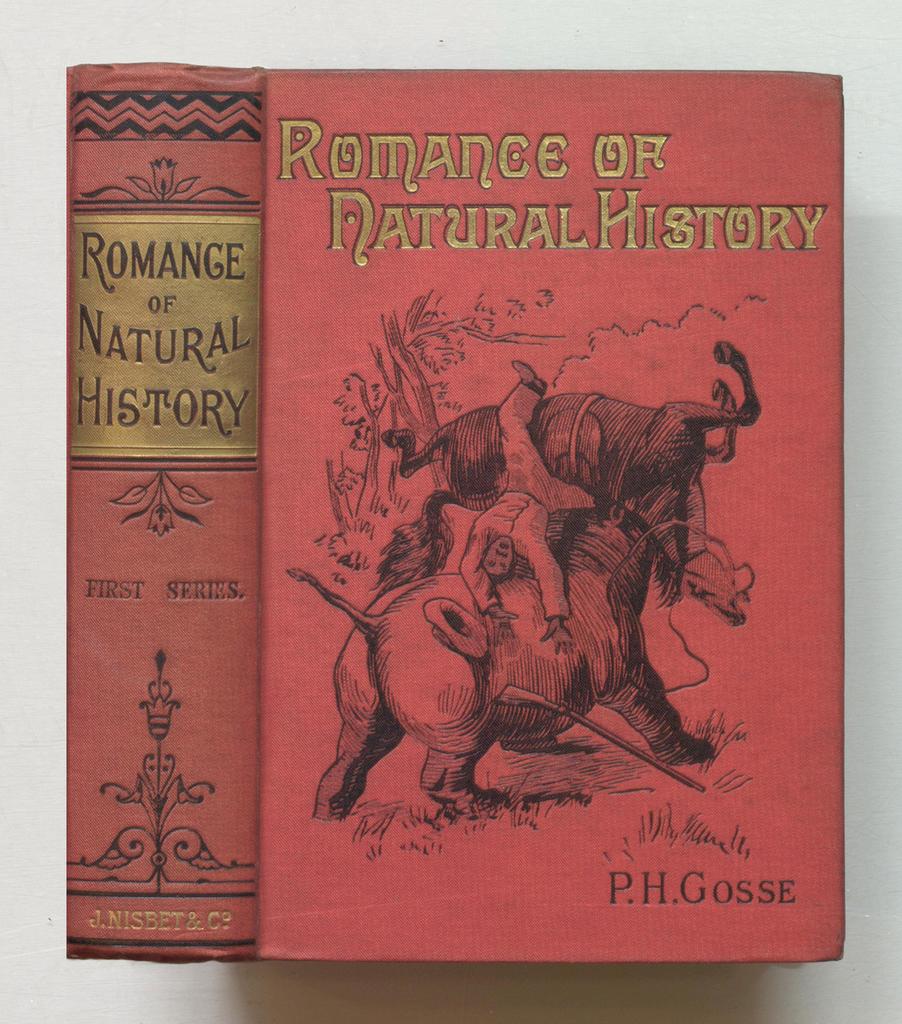Who penned the novel?
Make the answer very short. P.h. gosse. What is the title of the book?
Your response must be concise. Romance of natural history. 